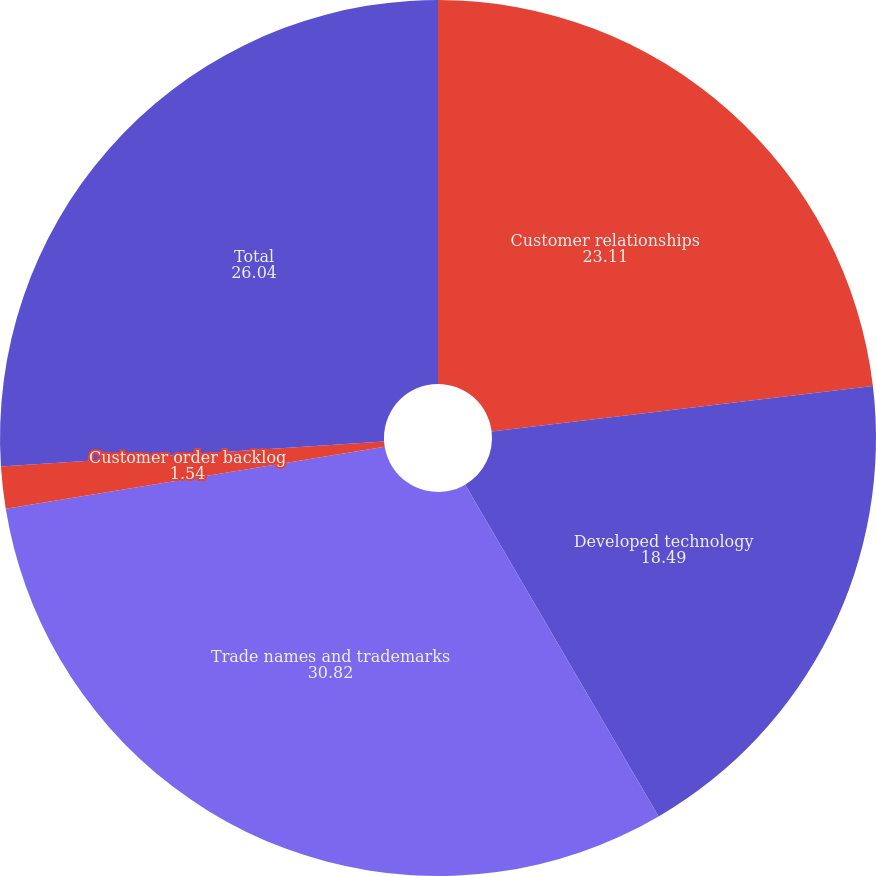<chart> <loc_0><loc_0><loc_500><loc_500><pie_chart><fcel>Customer relationships<fcel>Developed technology<fcel>Trade names and trademarks<fcel>Customer order backlog<fcel>Total<nl><fcel>23.11%<fcel>18.49%<fcel>30.82%<fcel>1.54%<fcel>26.04%<nl></chart> 